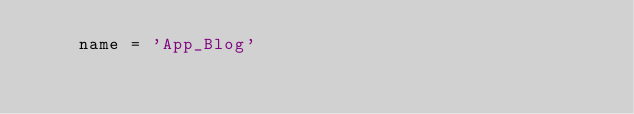Convert code to text. <code><loc_0><loc_0><loc_500><loc_500><_Python_>    name = 'App_Blog'
</code> 